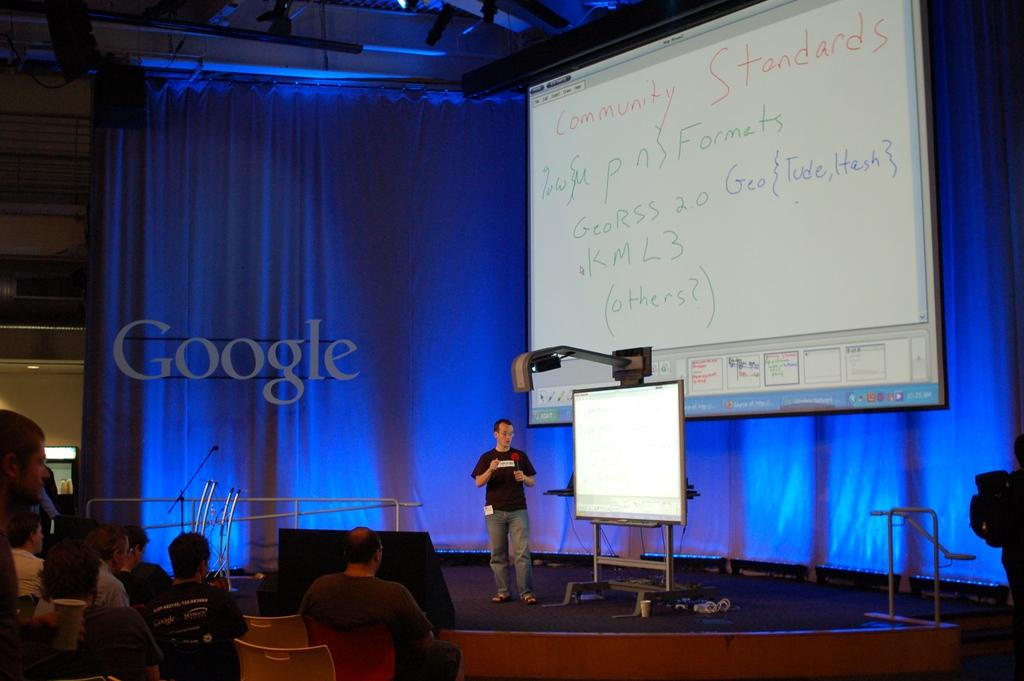What is the main subject in the center of the image? There is a person standing at the screen on the dais in the center of the image. What can be seen at the bottom of the image? There is a crowd visible at the bottom of the image. What is present in the background of the image? There is a curtain and a screen in the background of the image. What is the moon doing in the image? The moon is not present in the image; it is not a part of the scene depicted. 